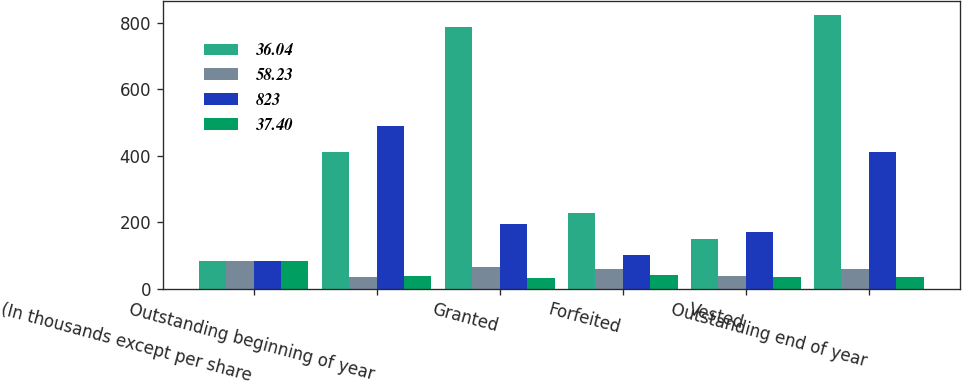<chart> <loc_0><loc_0><loc_500><loc_500><stacked_bar_chart><ecel><fcel>(In thousands except per share<fcel>Outstanding beginning of year<fcel>Granted<fcel>Forfeited<fcel>Vested<fcel>Outstanding end of year<nl><fcel>36.04<fcel>84.095<fcel>412<fcel>788<fcel>227<fcel>150<fcel>823<nl><fcel>58.23<fcel>84.095<fcel>36.04<fcel>66.19<fcel>59.52<fcel>37.19<fcel>58.23<nl><fcel>823<fcel>84.095<fcel>488<fcel>195<fcel>102<fcel>169<fcel>412<nl><fcel>37.4<fcel>84.095<fcel>37.4<fcel>33.46<fcel>39.68<fcel>34.81<fcel>36.04<nl></chart> 